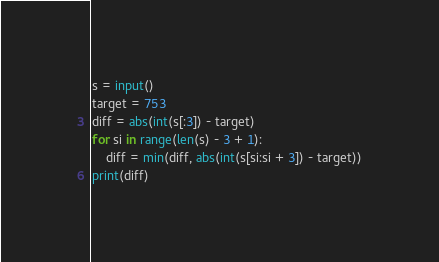<code> <loc_0><loc_0><loc_500><loc_500><_Python_>s = input()
target = 753
diff = abs(int(s[:3]) - target)
for si in range(len(s) - 3 + 1):
    diff = min(diff, abs(int(s[si:si + 3]) - target))
print(diff)
</code> 